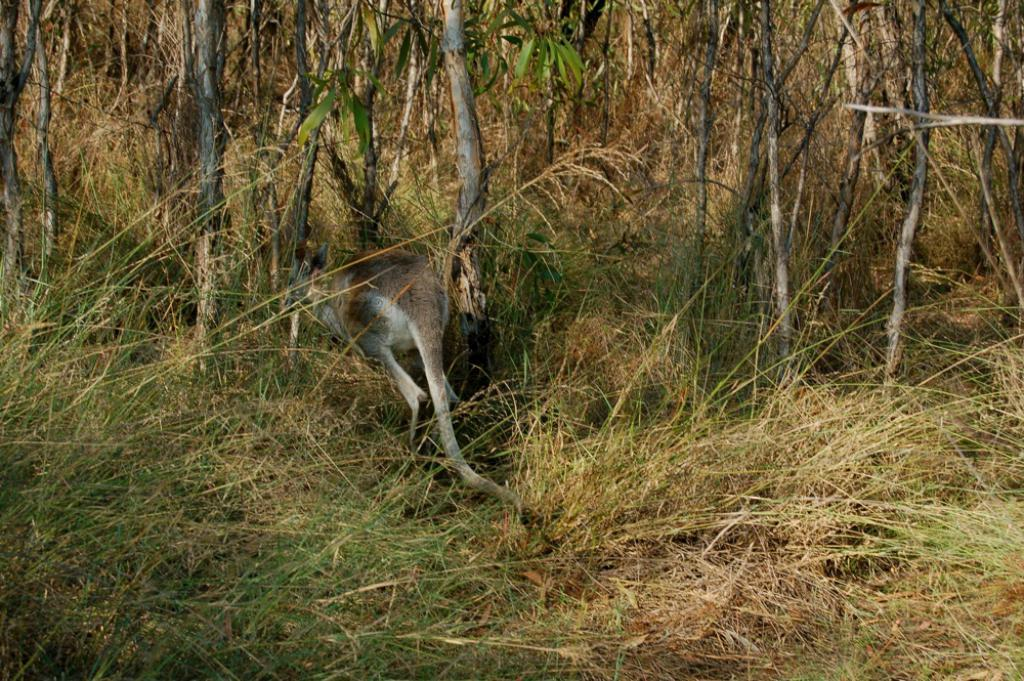What type of animal is in the image? The type of animal cannot be determined from the provided facts. Where is the animal located in the image? The animal is on the grass. What other natural elements are present in the image? There are trees in the image. How many trucks are parked near the animal in the image? There is no mention of trucks in the image, so it cannot be determined if any are present. 